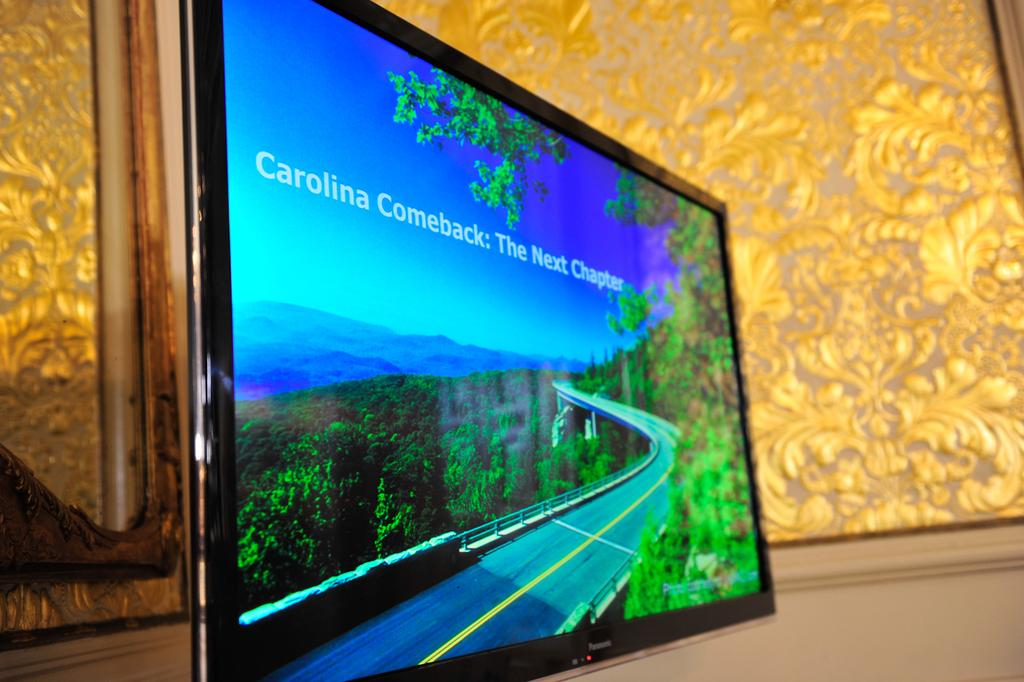<image>
Create a compact narrative representing the image presented. a screen with the word comeback on it 